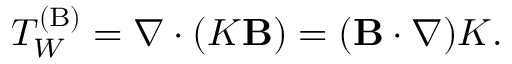<formula> <loc_0><loc_0><loc_500><loc_500>T _ { W } ^ { ( { B } ) } = \nabla \cdot ( K { B } ) = ( { B } \cdot \nabla ) K .</formula> 